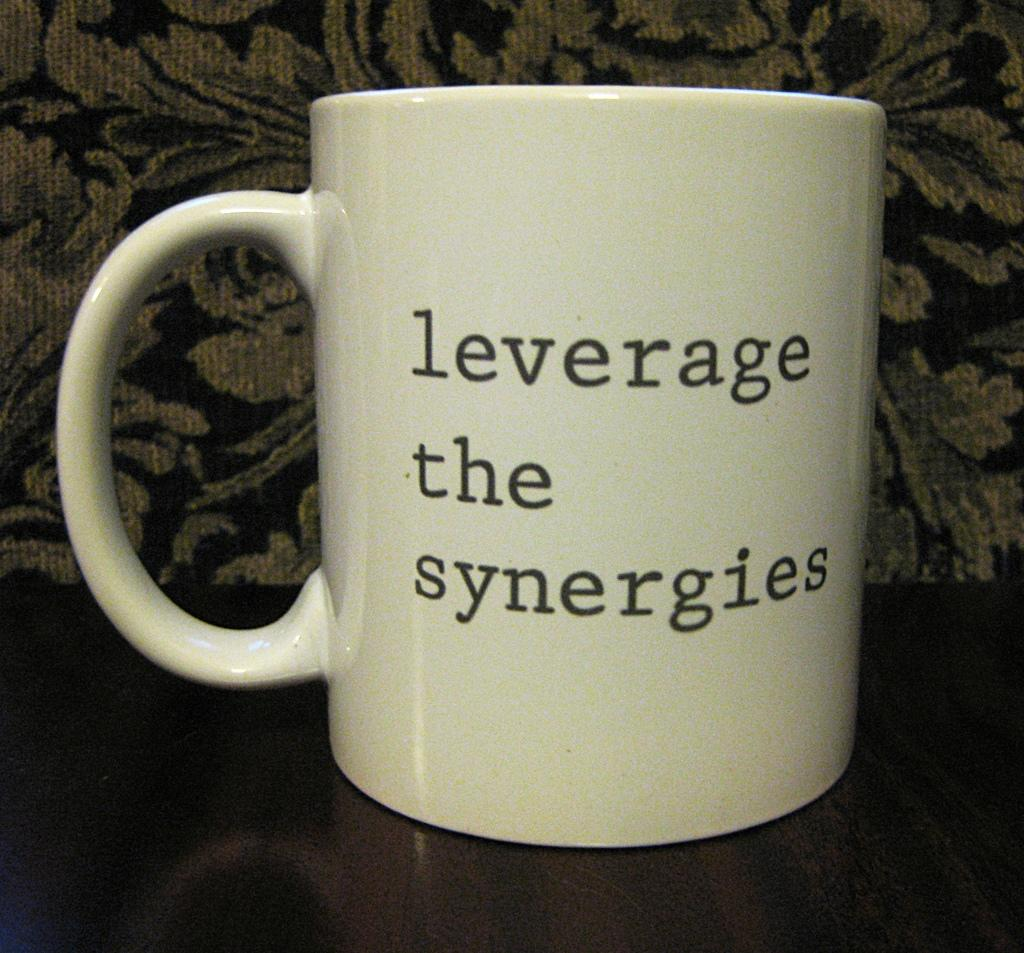Provide a one-sentence caption for the provided image. The beige coffee cup says "Leverage the synergies". 